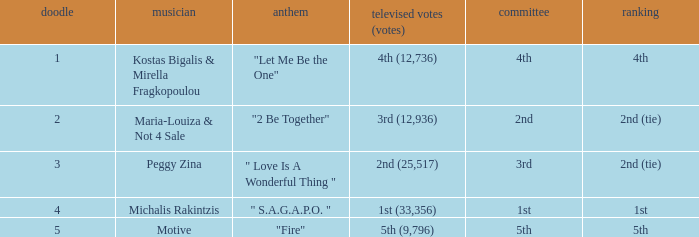Singer Maria-Louiza & Not 4 Sale had what jury? 2nd. 